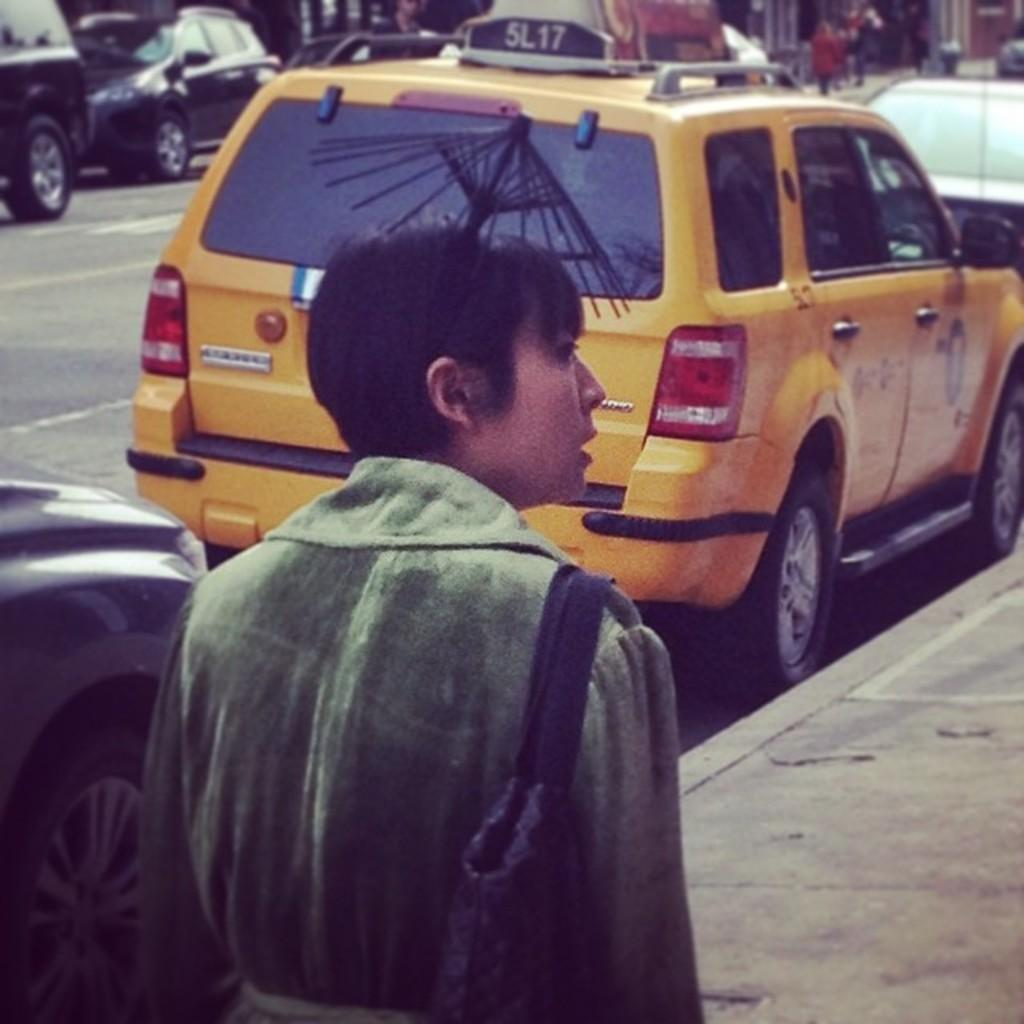<image>
Share a concise interpretation of the image provided. A person walks on a sidewalk in front of a taxi with a sign that says 5L17 on the roof. 